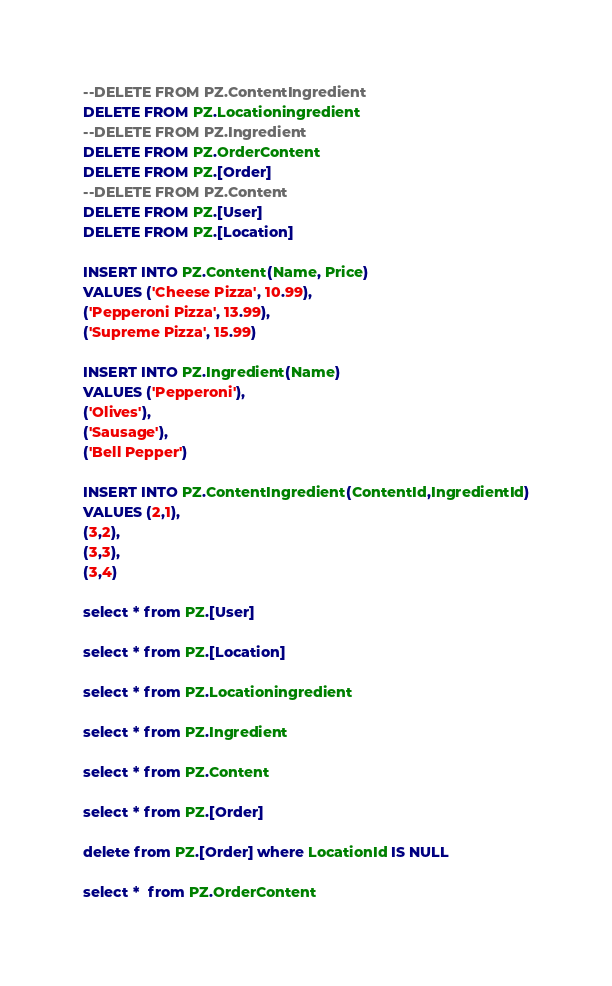Convert code to text. <code><loc_0><loc_0><loc_500><loc_500><_SQL_>
--DELETE FROM PZ.ContentIngredient
DELETE FROM PZ.Locationingredient
--DELETE FROM PZ.Ingredient
DELETE FROM PZ.OrderContent
DELETE FROM PZ.[Order]
--DELETE FROM PZ.Content
DELETE FROM PZ.[User]
DELETE FROM PZ.[Location]

INSERT INTO PZ.Content(Name, Price)
VALUES ('Cheese Pizza', 10.99),
('Pepperoni Pizza', 13.99),
('Supreme Pizza', 15.99)

INSERT INTO PZ.Ingredient(Name)
VALUES ('Pepperoni'),
('Olives'),
('Sausage'),
('Bell Pepper')

INSERT INTO PZ.ContentIngredient(ContentId,IngredientId)
VALUES (2,1),
(3,2),
(3,3),
(3,4)

select * from PZ.[User]

select * from PZ.[Location]

select * from PZ.Locationingredient

select * from PZ.Ingredient

select * from PZ.Content

select * from PZ.[Order]

delete from PZ.[Order] where LocationId IS NULL

select *  from PZ.OrderContent</code> 